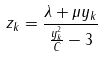Convert formula to latex. <formula><loc_0><loc_0><loc_500><loc_500>z _ { k } = \frac { \lambda + \mu y _ { k } } { \frac { y _ { k } ^ { 2 } } { C } - 3 }</formula> 